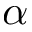<formula> <loc_0><loc_0><loc_500><loc_500>\alpha</formula> 